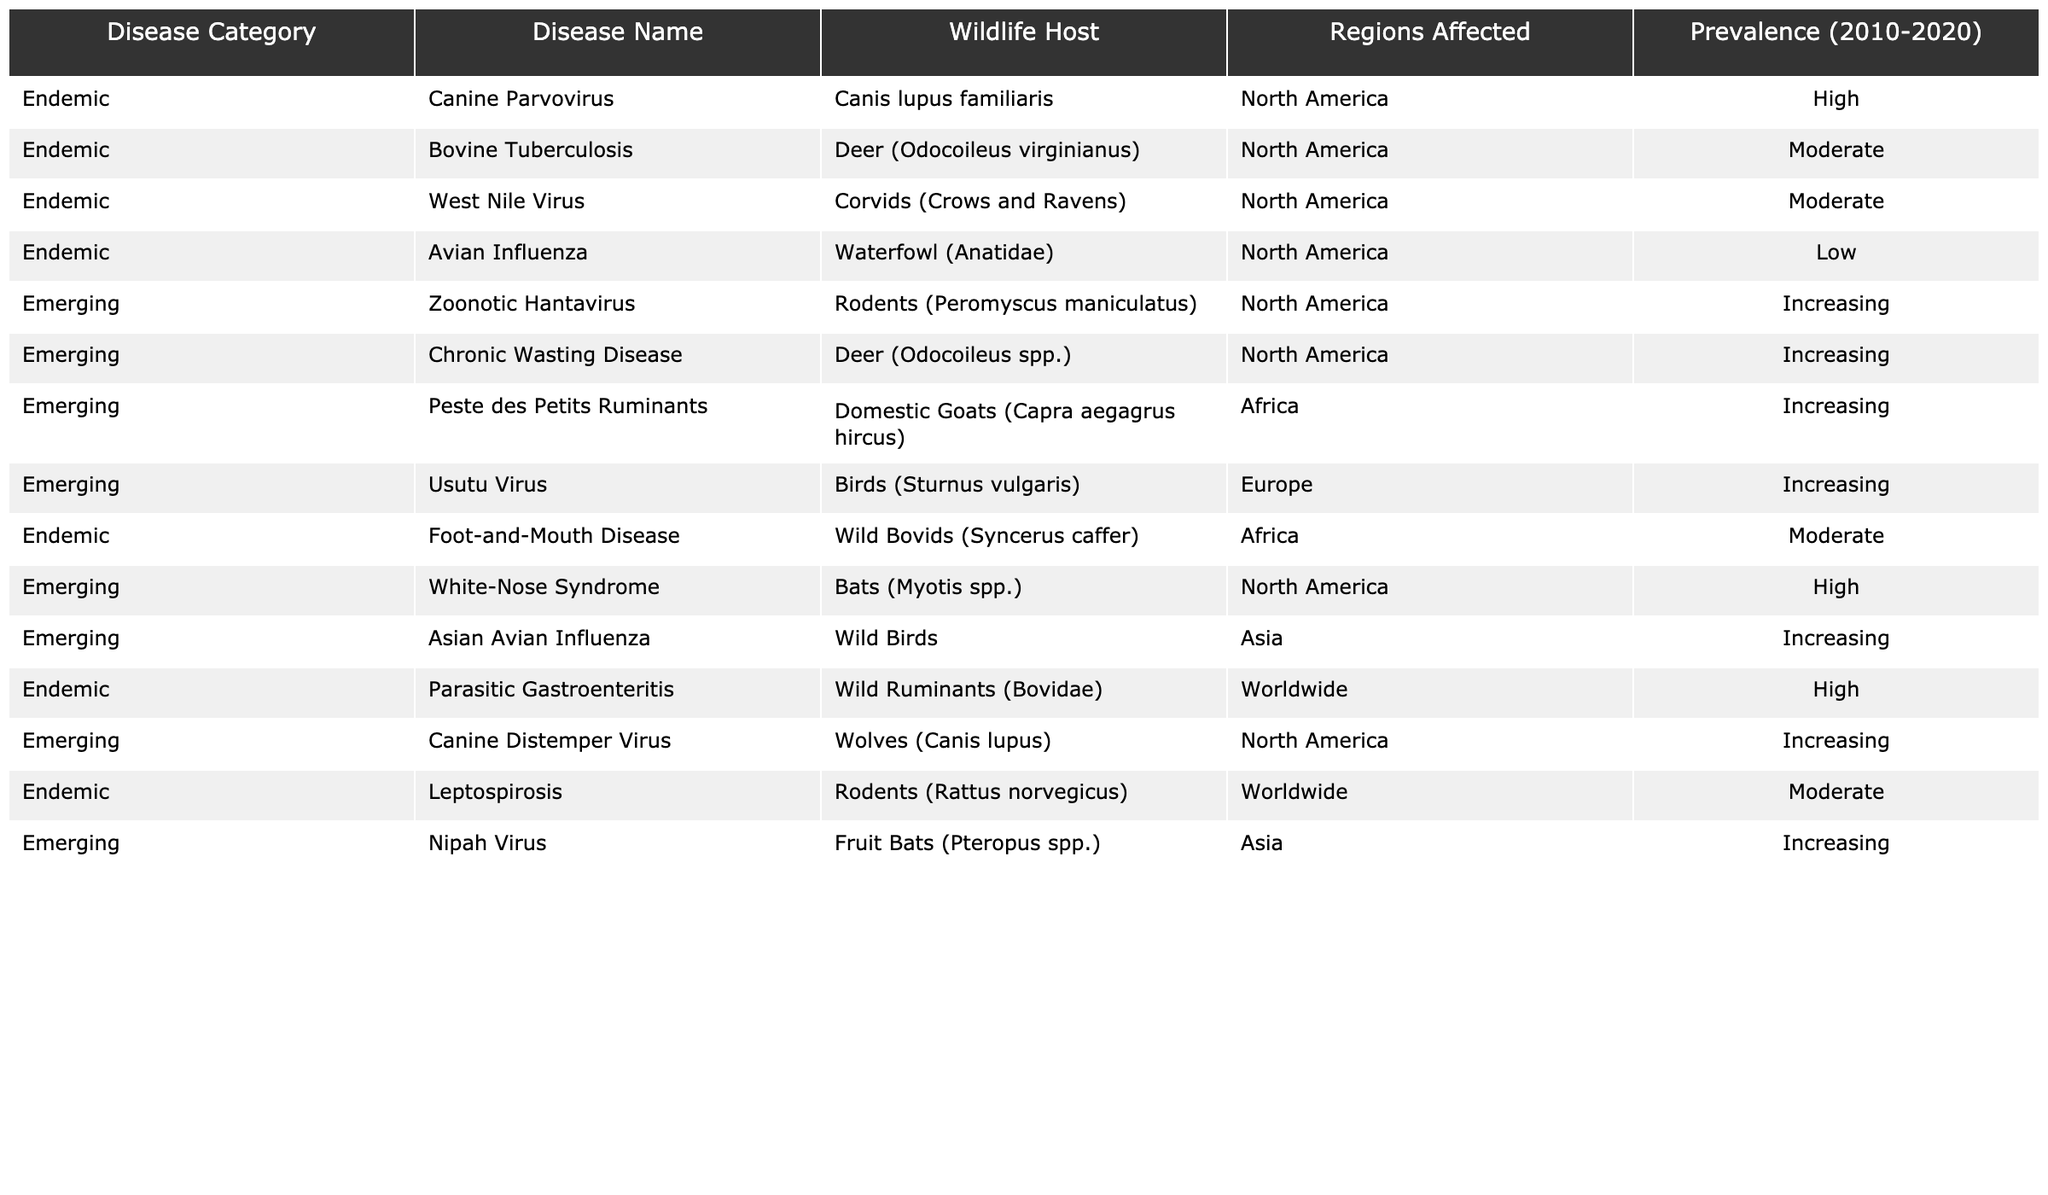What is the most prevalent endemic disease in wildlife from the table? According to the table, "Parasitic Gastroenteritis" has a prevalence of "High," which is the highest ranking in that category.
Answer: Parasitic Gastroenteritis What regions are affected by the disease "Chronic Wasting Disease"? The table states that "Chronic Wasting Disease" affects North America.
Answer: North America How many diseases are classified as emerging in North America? There are four diseases listed as emerging in North America: "Zoonotic Hantavirus," "Chronic Wasting Disease," "White-Nose Syndrome," and "Canine Distemper Virus."
Answer: Four Is "West Nile Virus" considered an emerging disease? The table indicates that "West Nile Virus" is listed under the endemic category, so it is not considered emerging.
Answer: No What is the prevalence of "Nipah Virus" according to the table? The table shows that "Nipah Virus" has an "Increasing" prevalence ranking, indicating its prevalence is rising.
Answer: Increasing Which wildlife host is associated with the highest prevalence disease listed in the table? "White-Nose Syndrome," associated with bats, is listed as having a "High" prevalence, making it the highest among emerging diseases.
Answer: Bats How many diseases in Africa have a moderate prevalence? The table includes "Foot-and-Mouth Disease," which is moderate for Africa and does not list any others, giving a total of one.
Answer: One What disease has the lowest prevalence ranking in this table? "Avian Influenza" is stated to have a "Low" prevalence ranking, which is the lowest in the list.
Answer: Avian Influenza What is the difference between the number of endemic and emerging diseases listed? There are 5 endemic diseases and 6 emerging diseases. So, the difference is 6 - 5 = 1.
Answer: One Which region has the most diversity in diseases, both endemic and emerging? North America has the most entries listed, with a mix of both endemic and emerging diseases (7 total).
Answer: North America 